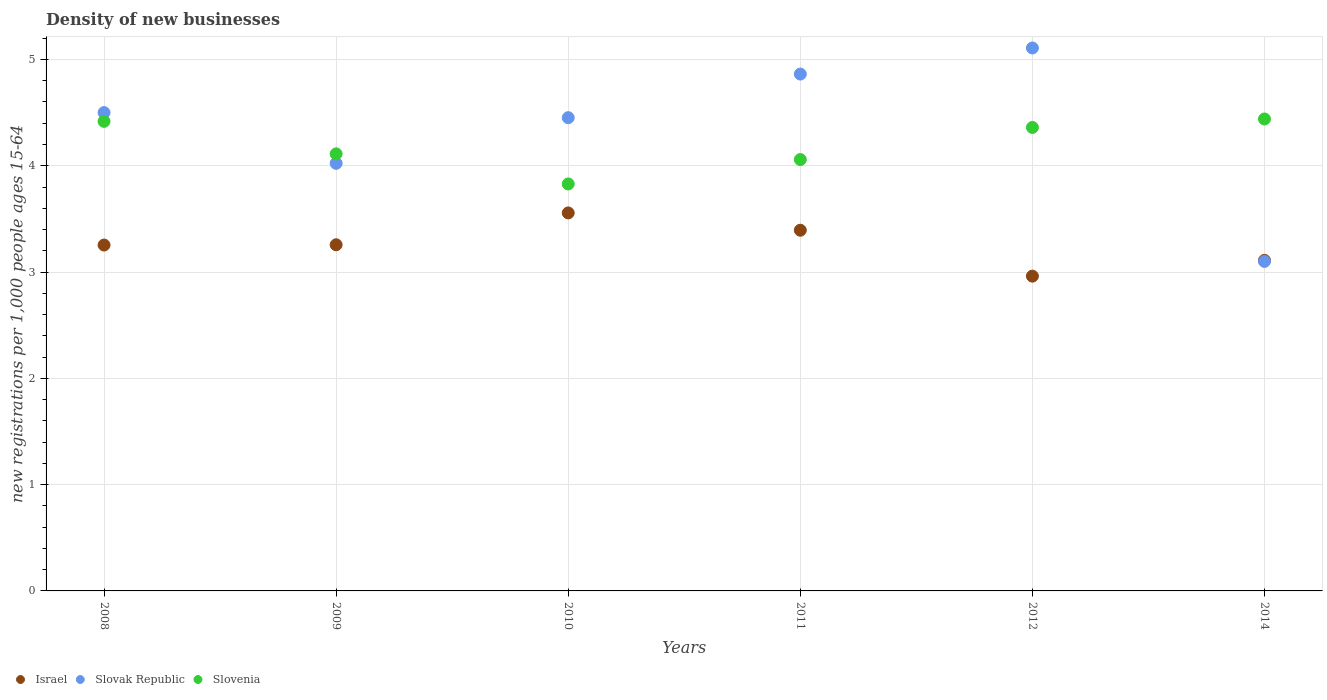How many different coloured dotlines are there?
Offer a very short reply. 3. Is the number of dotlines equal to the number of legend labels?
Make the answer very short. Yes. What is the number of new registrations in Israel in 2012?
Your response must be concise. 2.96. Across all years, what is the maximum number of new registrations in Slovenia?
Offer a terse response. 4.44. Across all years, what is the minimum number of new registrations in Slovenia?
Make the answer very short. 3.83. What is the total number of new registrations in Slovenia in the graph?
Provide a short and direct response. 25.22. What is the difference between the number of new registrations in Slovak Republic in 2008 and that in 2010?
Your answer should be very brief. 0.05. What is the difference between the number of new registrations in Israel in 2014 and the number of new registrations in Slovenia in 2010?
Provide a succinct answer. -0.72. What is the average number of new registrations in Israel per year?
Offer a very short reply. 3.26. In the year 2014, what is the difference between the number of new registrations in Slovenia and number of new registrations in Slovak Republic?
Provide a succinct answer. 1.34. What is the ratio of the number of new registrations in Slovenia in 2011 to that in 2012?
Provide a short and direct response. 0.93. Is the difference between the number of new registrations in Slovenia in 2008 and 2011 greater than the difference between the number of new registrations in Slovak Republic in 2008 and 2011?
Your answer should be very brief. Yes. What is the difference between the highest and the second highest number of new registrations in Slovenia?
Offer a terse response. 0.02. What is the difference between the highest and the lowest number of new registrations in Israel?
Your answer should be compact. 0.59. In how many years, is the number of new registrations in Slovenia greater than the average number of new registrations in Slovenia taken over all years?
Your response must be concise. 3. Is it the case that in every year, the sum of the number of new registrations in Slovenia and number of new registrations in Israel  is greater than the number of new registrations in Slovak Republic?
Make the answer very short. Yes. Is the number of new registrations in Slovak Republic strictly greater than the number of new registrations in Slovenia over the years?
Ensure brevity in your answer.  No. What is the difference between two consecutive major ticks on the Y-axis?
Provide a short and direct response. 1. Does the graph contain any zero values?
Your answer should be compact. No. How many legend labels are there?
Keep it short and to the point. 3. How are the legend labels stacked?
Your answer should be compact. Horizontal. What is the title of the graph?
Ensure brevity in your answer.  Density of new businesses. What is the label or title of the Y-axis?
Provide a succinct answer. New registrations per 1,0 people ages 15-64. What is the new registrations per 1,000 people ages 15-64 of Israel in 2008?
Give a very brief answer. 3.25. What is the new registrations per 1,000 people ages 15-64 in Slovak Republic in 2008?
Give a very brief answer. 4.5. What is the new registrations per 1,000 people ages 15-64 of Slovenia in 2008?
Your response must be concise. 4.42. What is the new registrations per 1,000 people ages 15-64 in Israel in 2009?
Make the answer very short. 3.26. What is the new registrations per 1,000 people ages 15-64 of Slovak Republic in 2009?
Your answer should be compact. 4.02. What is the new registrations per 1,000 people ages 15-64 of Slovenia in 2009?
Ensure brevity in your answer.  4.11. What is the new registrations per 1,000 people ages 15-64 of Israel in 2010?
Ensure brevity in your answer.  3.56. What is the new registrations per 1,000 people ages 15-64 in Slovak Republic in 2010?
Offer a terse response. 4.45. What is the new registrations per 1,000 people ages 15-64 of Slovenia in 2010?
Offer a very short reply. 3.83. What is the new registrations per 1,000 people ages 15-64 of Israel in 2011?
Your answer should be very brief. 3.39. What is the new registrations per 1,000 people ages 15-64 in Slovak Republic in 2011?
Make the answer very short. 4.86. What is the new registrations per 1,000 people ages 15-64 of Slovenia in 2011?
Your answer should be very brief. 4.06. What is the new registrations per 1,000 people ages 15-64 of Israel in 2012?
Ensure brevity in your answer.  2.96. What is the new registrations per 1,000 people ages 15-64 of Slovak Republic in 2012?
Provide a succinct answer. 5.11. What is the new registrations per 1,000 people ages 15-64 of Slovenia in 2012?
Your answer should be compact. 4.36. What is the new registrations per 1,000 people ages 15-64 in Israel in 2014?
Make the answer very short. 3.11. What is the new registrations per 1,000 people ages 15-64 in Slovak Republic in 2014?
Provide a succinct answer. 3.1. What is the new registrations per 1,000 people ages 15-64 of Slovenia in 2014?
Offer a terse response. 4.44. Across all years, what is the maximum new registrations per 1,000 people ages 15-64 in Israel?
Offer a very short reply. 3.56. Across all years, what is the maximum new registrations per 1,000 people ages 15-64 in Slovak Republic?
Offer a very short reply. 5.11. Across all years, what is the maximum new registrations per 1,000 people ages 15-64 in Slovenia?
Your answer should be very brief. 4.44. Across all years, what is the minimum new registrations per 1,000 people ages 15-64 of Israel?
Keep it short and to the point. 2.96. Across all years, what is the minimum new registrations per 1,000 people ages 15-64 in Slovenia?
Provide a short and direct response. 3.83. What is the total new registrations per 1,000 people ages 15-64 in Israel in the graph?
Offer a terse response. 19.53. What is the total new registrations per 1,000 people ages 15-64 of Slovak Republic in the graph?
Make the answer very short. 26.05. What is the total new registrations per 1,000 people ages 15-64 of Slovenia in the graph?
Your answer should be very brief. 25.22. What is the difference between the new registrations per 1,000 people ages 15-64 of Israel in 2008 and that in 2009?
Ensure brevity in your answer.  -0. What is the difference between the new registrations per 1,000 people ages 15-64 in Slovak Republic in 2008 and that in 2009?
Your answer should be compact. 0.48. What is the difference between the new registrations per 1,000 people ages 15-64 of Slovenia in 2008 and that in 2009?
Provide a short and direct response. 0.31. What is the difference between the new registrations per 1,000 people ages 15-64 of Israel in 2008 and that in 2010?
Provide a short and direct response. -0.3. What is the difference between the new registrations per 1,000 people ages 15-64 in Slovak Republic in 2008 and that in 2010?
Provide a succinct answer. 0.05. What is the difference between the new registrations per 1,000 people ages 15-64 of Slovenia in 2008 and that in 2010?
Offer a terse response. 0.59. What is the difference between the new registrations per 1,000 people ages 15-64 of Israel in 2008 and that in 2011?
Provide a short and direct response. -0.14. What is the difference between the new registrations per 1,000 people ages 15-64 of Slovak Republic in 2008 and that in 2011?
Your answer should be very brief. -0.36. What is the difference between the new registrations per 1,000 people ages 15-64 in Slovenia in 2008 and that in 2011?
Offer a terse response. 0.36. What is the difference between the new registrations per 1,000 people ages 15-64 of Israel in 2008 and that in 2012?
Keep it short and to the point. 0.29. What is the difference between the new registrations per 1,000 people ages 15-64 in Slovak Republic in 2008 and that in 2012?
Your answer should be very brief. -0.61. What is the difference between the new registrations per 1,000 people ages 15-64 in Slovenia in 2008 and that in 2012?
Your answer should be compact. 0.06. What is the difference between the new registrations per 1,000 people ages 15-64 in Israel in 2008 and that in 2014?
Provide a short and direct response. 0.14. What is the difference between the new registrations per 1,000 people ages 15-64 of Slovak Republic in 2008 and that in 2014?
Offer a very short reply. 1.4. What is the difference between the new registrations per 1,000 people ages 15-64 in Slovenia in 2008 and that in 2014?
Offer a very short reply. -0.02. What is the difference between the new registrations per 1,000 people ages 15-64 in Israel in 2009 and that in 2010?
Ensure brevity in your answer.  -0.3. What is the difference between the new registrations per 1,000 people ages 15-64 in Slovak Republic in 2009 and that in 2010?
Offer a terse response. -0.43. What is the difference between the new registrations per 1,000 people ages 15-64 of Slovenia in 2009 and that in 2010?
Keep it short and to the point. 0.28. What is the difference between the new registrations per 1,000 people ages 15-64 of Israel in 2009 and that in 2011?
Your response must be concise. -0.14. What is the difference between the new registrations per 1,000 people ages 15-64 in Slovak Republic in 2009 and that in 2011?
Provide a succinct answer. -0.84. What is the difference between the new registrations per 1,000 people ages 15-64 of Slovenia in 2009 and that in 2011?
Ensure brevity in your answer.  0.05. What is the difference between the new registrations per 1,000 people ages 15-64 of Israel in 2009 and that in 2012?
Your response must be concise. 0.3. What is the difference between the new registrations per 1,000 people ages 15-64 in Slovak Republic in 2009 and that in 2012?
Offer a terse response. -1.09. What is the difference between the new registrations per 1,000 people ages 15-64 of Slovenia in 2009 and that in 2012?
Your response must be concise. -0.25. What is the difference between the new registrations per 1,000 people ages 15-64 in Israel in 2009 and that in 2014?
Offer a terse response. 0.15. What is the difference between the new registrations per 1,000 people ages 15-64 in Slovak Republic in 2009 and that in 2014?
Keep it short and to the point. 0.92. What is the difference between the new registrations per 1,000 people ages 15-64 in Slovenia in 2009 and that in 2014?
Keep it short and to the point. -0.33. What is the difference between the new registrations per 1,000 people ages 15-64 in Israel in 2010 and that in 2011?
Provide a short and direct response. 0.16. What is the difference between the new registrations per 1,000 people ages 15-64 of Slovak Republic in 2010 and that in 2011?
Offer a terse response. -0.41. What is the difference between the new registrations per 1,000 people ages 15-64 of Slovenia in 2010 and that in 2011?
Make the answer very short. -0.23. What is the difference between the new registrations per 1,000 people ages 15-64 of Israel in 2010 and that in 2012?
Your answer should be compact. 0.59. What is the difference between the new registrations per 1,000 people ages 15-64 of Slovak Republic in 2010 and that in 2012?
Keep it short and to the point. -0.66. What is the difference between the new registrations per 1,000 people ages 15-64 of Slovenia in 2010 and that in 2012?
Give a very brief answer. -0.53. What is the difference between the new registrations per 1,000 people ages 15-64 in Israel in 2010 and that in 2014?
Keep it short and to the point. 0.45. What is the difference between the new registrations per 1,000 people ages 15-64 in Slovak Republic in 2010 and that in 2014?
Make the answer very short. 1.35. What is the difference between the new registrations per 1,000 people ages 15-64 in Slovenia in 2010 and that in 2014?
Keep it short and to the point. -0.61. What is the difference between the new registrations per 1,000 people ages 15-64 in Israel in 2011 and that in 2012?
Offer a very short reply. 0.43. What is the difference between the new registrations per 1,000 people ages 15-64 in Slovak Republic in 2011 and that in 2012?
Keep it short and to the point. -0.25. What is the difference between the new registrations per 1,000 people ages 15-64 of Slovenia in 2011 and that in 2012?
Make the answer very short. -0.3. What is the difference between the new registrations per 1,000 people ages 15-64 in Israel in 2011 and that in 2014?
Keep it short and to the point. 0.28. What is the difference between the new registrations per 1,000 people ages 15-64 of Slovak Republic in 2011 and that in 2014?
Your answer should be very brief. 1.76. What is the difference between the new registrations per 1,000 people ages 15-64 in Slovenia in 2011 and that in 2014?
Your answer should be compact. -0.38. What is the difference between the new registrations per 1,000 people ages 15-64 in Israel in 2012 and that in 2014?
Provide a succinct answer. -0.15. What is the difference between the new registrations per 1,000 people ages 15-64 in Slovak Republic in 2012 and that in 2014?
Make the answer very short. 2.01. What is the difference between the new registrations per 1,000 people ages 15-64 of Slovenia in 2012 and that in 2014?
Ensure brevity in your answer.  -0.08. What is the difference between the new registrations per 1,000 people ages 15-64 of Israel in 2008 and the new registrations per 1,000 people ages 15-64 of Slovak Republic in 2009?
Ensure brevity in your answer.  -0.77. What is the difference between the new registrations per 1,000 people ages 15-64 of Israel in 2008 and the new registrations per 1,000 people ages 15-64 of Slovenia in 2009?
Your response must be concise. -0.86. What is the difference between the new registrations per 1,000 people ages 15-64 in Slovak Republic in 2008 and the new registrations per 1,000 people ages 15-64 in Slovenia in 2009?
Provide a short and direct response. 0.39. What is the difference between the new registrations per 1,000 people ages 15-64 in Israel in 2008 and the new registrations per 1,000 people ages 15-64 in Slovak Republic in 2010?
Your answer should be very brief. -1.2. What is the difference between the new registrations per 1,000 people ages 15-64 in Israel in 2008 and the new registrations per 1,000 people ages 15-64 in Slovenia in 2010?
Offer a terse response. -0.57. What is the difference between the new registrations per 1,000 people ages 15-64 in Slovak Republic in 2008 and the new registrations per 1,000 people ages 15-64 in Slovenia in 2010?
Your response must be concise. 0.67. What is the difference between the new registrations per 1,000 people ages 15-64 of Israel in 2008 and the new registrations per 1,000 people ages 15-64 of Slovak Republic in 2011?
Offer a terse response. -1.61. What is the difference between the new registrations per 1,000 people ages 15-64 of Israel in 2008 and the new registrations per 1,000 people ages 15-64 of Slovenia in 2011?
Your answer should be compact. -0.8. What is the difference between the new registrations per 1,000 people ages 15-64 of Slovak Republic in 2008 and the new registrations per 1,000 people ages 15-64 of Slovenia in 2011?
Ensure brevity in your answer.  0.44. What is the difference between the new registrations per 1,000 people ages 15-64 of Israel in 2008 and the new registrations per 1,000 people ages 15-64 of Slovak Republic in 2012?
Offer a terse response. -1.85. What is the difference between the new registrations per 1,000 people ages 15-64 of Israel in 2008 and the new registrations per 1,000 people ages 15-64 of Slovenia in 2012?
Provide a short and direct response. -1.11. What is the difference between the new registrations per 1,000 people ages 15-64 of Slovak Republic in 2008 and the new registrations per 1,000 people ages 15-64 of Slovenia in 2012?
Keep it short and to the point. 0.14. What is the difference between the new registrations per 1,000 people ages 15-64 of Israel in 2008 and the new registrations per 1,000 people ages 15-64 of Slovak Republic in 2014?
Your answer should be very brief. 0.15. What is the difference between the new registrations per 1,000 people ages 15-64 of Israel in 2008 and the new registrations per 1,000 people ages 15-64 of Slovenia in 2014?
Offer a terse response. -1.19. What is the difference between the new registrations per 1,000 people ages 15-64 in Slovak Republic in 2008 and the new registrations per 1,000 people ages 15-64 in Slovenia in 2014?
Give a very brief answer. 0.06. What is the difference between the new registrations per 1,000 people ages 15-64 in Israel in 2009 and the new registrations per 1,000 people ages 15-64 in Slovak Republic in 2010?
Ensure brevity in your answer.  -1.2. What is the difference between the new registrations per 1,000 people ages 15-64 in Israel in 2009 and the new registrations per 1,000 people ages 15-64 in Slovenia in 2010?
Offer a very short reply. -0.57. What is the difference between the new registrations per 1,000 people ages 15-64 of Slovak Republic in 2009 and the new registrations per 1,000 people ages 15-64 of Slovenia in 2010?
Offer a terse response. 0.19. What is the difference between the new registrations per 1,000 people ages 15-64 of Israel in 2009 and the new registrations per 1,000 people ages 15-64 of Slovak Republic in 2011?
Your answer should be very brief. -1.61. What is the difference between the new registrations per 1,000 people ages 15-64 in Israel in 2009 and the new registrations per 1,000 people ages 15-64 in Slovenia in 2011?
Ensure brevity in your answer.  -0.8. What is the difference between the new registrations per 1,000 people ages 15-64 of Slovak Republic in 2009 and the new registrations per 1,000 people ages 15-64 of Slovenia in 2011?
Make the answer very short. -0.04. What is the difference between the new registrations per 1,000 people ages 15-64 in Israel in 2009 and the new registrations per 1,000 people ages 15-64 in Slovak Republic in 2012?
Make the answer very short. -1.85. What is the difference between the new registrations per 1,000 people ages 15-64 of Israel in 2009 and the new registrations per 1,000 people ages 15-64 of Slovenia in 2012?
Offer a terse response. -1.1. What is the difference between the new registrations per 1,000 people ages 15-64 in Slovak Republic in 2009 and the new registrations per 1,000 people ages 15-64 in Slovenia in 2012?
Offer a very short reply. -0.34. What is the difference between the new registrations per 1,000 people ages 15-64 of Israel in 2009 and the new registrations per 1,000 people ages 15-64 of Slovak Republic in 2014?
Your response must be concise. 0.16. What is the difference between the new registrations per 1,000 people ages 15-64 in Israel in 2009 and the new registrations per 1,000 people ages 15-64 in Slovenia in 2014?
Ensure brevity in your answer.  -1.18. What is the difference between the new registrations per 1,000 people ages 15-64 in Slovak Republic in 2009 and the new registrations per 1,000 people ages 15-64 in Slovenia in 2014?
Make the answer very short. -0.42. What is the difference between the new registrations per 1,000 people ages 15-64 in Israel in 2010 and the new registrations per 1,000 people ages 15-64 in Slovak Republic in 2011?
Make the answer very short. -1.31. What is the difference between the new registrations per 1,000 people ages 15-64 of Israel in 2010 and the new registrations per 1,000 people ages 15-64 of Slovenia in 2011?
Your answer should be compact. -0.5. What is the difference between the new registrations per 1,000 people ages 15-64 of Slovak Republic in 2010 and the new registrations per 1,000 people ages 15-64 of Slovenia in 2011?
Your response must be concise. 0.39. What is the difference between the new registrations per 1,000 people ages 15-64 in Israel in 2010 and the new registrations per 1,000 people ages 15-64 in Slovak Republic in 2012?
Your answer should be compact. -1.55. What is the difference between the new registrations per 1,000 people ages 15-64 in Israel in 2010 and the new registrations per 1,000 people ages 15-64 in Slovenia in 2012?
Your answer should be very brief. -0.8. What is the difference between the new registrations per 1,000 people ages 15-64 of Slovak Republic in 2010 and the new registrations per 1,000 people ages 15-64 of Slovenia in 2012?
Your answer should be compact. 0.09. What is the difference between the new registrations per 1,000 people ages 15-64 of Israel in 2010 and the new registrations per 1,000 people ages 15-64 of Slovak Republic in 2014?
Make the answer very short. 0.46. What is the difference between the new registrations per 1,000 people ages 15-64 of Israel in 2010 and the new registrations per 1,000 people ages 15-64 of Slovenia in 2014?
Provide a succinct answer. -0.88. What is the difference between the new registrations per 1,000 people ages 15-64 of Slovak Republic in 2010 and the new registrations per 1,000 people ages 15-64 of Slovenia in 2014?
Offer a very short reply. 0.01. What is the difference between the new registrations per 1,000 people ages 15-64 in Israel in 2011 and the new registrations per 1,000 people ages 15-64 in Slovak Republic in 2012?
Provide a short and direct response. -1.71. What is the difference between the new registrations per 1,000 people ages 15-64 in Israel in 2011 and the new registrations per 1,000 people ages 15-64 in Slovenia in 2012?
Your response must be concise. -0.97. What is the difference between the new registrations per 1,000 people ages 15-64 in Slovak Republic in 2011 and the new registrations per 1,000 people ages 15-64 in Slovenia in 2012?
Offer a terse response. 0.5. What is the difference between the new registrations per 1,000 people ages 15-64 in Israel in 2011 and the new registrations per 1,000 people ages 15-64 in Slovak Republic in 2014?
Ensure brevity in your answer.  0.29. What is the difference between the new registrations per 1,000 people ages 15-64 of Israel in 2011 and the new registrations per 1,000 people ages 15-64 of Slovenia in 2014?
Offer a terse response. -1.05. What is the difference between the new registrations per 1,000 people ages 15-64 in Slovak Republic in 2011 and the new registrations per 1,000 people ages 15-64 in Slovenia in 2014?
Offer a terse response. 0.42. What is the difference between the new registrations per 1,000 people ages 15-64 of Israel in 2012 and the new registrations per 1,000 people ages 15-64 of Slovak Republic in 2014?
Your response must be concise. -0.14. What is the difference between the new registrations per 1,000 people ages 15-64 of Israel in 2012 and the new registrations per 1,000 people ages 15-64 of Slovenia in 2014?
Ensure brevity in your answer.  -1.48. What is the difference between the new registrations per 1,000 people ages 15-64 in Slovak Republic in 2012 and the new registrations per 1,000 people ages 15-64 in Slovenia in 2014?
Your response must be concise. 0.67. What is the average new registrations per 1,000 people ages 15-64 of Israel per year?
Keep it short and to the point. 3.26. What is the average new registrations per 1,000 people ages 15-64 in Slovak Republic per year?
Provide a short and direct response. 4.34. What is the average new registrations per 1,000 people ages 15-64 in Slovenia per year?
Keep it short and to the point. 4.2. In the year 2008, what is the difference between the new registrations per 1,000 people ages 15-64 of Israel and new registrations per 1,000 people ages 15-64 of Slovak Republic?
Your answer should be compact. -1.25. In the year 2008, what is the difference between the new registrations per 1,000 people ages 15-64 in Israel and new registrations per 1,000 people ages 15-64 in Slovenia?
Your answer should be very brief. -1.16. In the year 2008, what is the difference between the new registrations per 1,000 people ages 15-64 in Slovak Republic and new registrations per 1,000 people ages 15-64 in Slovenia?
Provide a succinct answer. 0.08. In the year 2009, what is the difference between the new registrations per 1,000 people ages 15-64 of Israel and new registrations per 1,000 people ages 15-64 of Slovak Republic?
Make the answer very short. -0.77. In the year 2009, what is the difference between the new registrations per 1,000 people ages 15-64 in Israel and new registrations per 1,000 people ages 15-64 in Slovenia?
Provide a short and direct response. -0.86. In the year 2009, what is the difference between the new registrations per 1,000 people ages 15-64 in Slovak Republic and new registrations per 1,000 people ages 15-64 in Slovenia?
Your response must be concise. -0.09. In the year 2010, what is the difference between the new registrations per 1,000 people ages 15-64 in Israel and new registrations per 1,000 people ages 15-64 in Slovak Republic?
Ensure brevity in your answer.  -0.9. In the year 2010, what is the difference between the new registrations per 1,000 people ages 15-64 in Israel and new registrations per 1,000 people ages 15-64 in Slovenia?
Make the answer very short. -0.27. In the year 2010, what is the difference between the new registrations per 1,000 people ages 15-64 in Slovak Republic and new registrations per 1,000 people ages 15-64 in Slovenia?
Provide a succinct answer. 0.62. In the year 2011, what is the difference between the new registrations per 1,000 people ages 15-64 in Israel and new registrations per 1,000 people ages 15-64 in Slovak Republic?
Keep it short and to the point. -1.47. In the year 2011, what is the difference between the new registrations per 1,000 people ages 15-64 in Israel and new registrations per 1,000 people ages 15-64 in Slovenia?
Offer a very short reply. -0.66. In the year 2011, what is the difference between the new registrations per 1,000 people ages 15-64 of Slovak Republic and new registrations per 1,000 people ages 15-64 of Slovenia?
Provide a succinct answer. 0.8. In the year 2012, what is the difference between the new registrations per 1,000 people ages 15-64 in Israel and new registrations per 1,000 people ages 15-64 in Slovak Republic?
Your answer should be compact. -2.15. In the year 2012, what is the difference between the new registrations per 1,000 people ages 15-64 in Israel and new registrations per 1,000 people ages 15-64 in Slovenia?
Provide a succinct answer. -1.4. In the year 2012, what is the difference between the new registrations per 1,000 people ages 15-64 of Slovak Republic and new registrations per 1,000 people ages 15-64 of Slovenia?
Offer a very short reply. 0.75. In the year 2014, what is the difference between the new registrations per 1,000 people ages 15-64 of Israel and new registrations per 1,000 people ages 15-64 of Slovenia?
Your response must be concise. -1.33. In the year 2014, what is the difference between the new registrations per 1,000 people ages 15-64 in Slovak Republic and new registrations per 1,000 people ages 15-64 in Slovenia?
Your response must be concise. -1.34. What is the ratio of the new registrations per 1,000 people ages 15-64 in Israel in 2008 to that in 2009?
Keep it short and to the point. 1. What is the ratio of the new registrations per 1,000 people ages 15-64 of Slovak Republic in 2008 to that in 2009?
Your answer should be compact. 1.12. What is the ratio of the new registrations per 1,000 people ages 15-64 in Slovenia in 2008 to that in 2009?
Your answer should be compact. 1.07. What is the ratio of the new registrations per 1,000 people ages 15-64 in Israel in 2008 to that in 2010?
Offer a terse response. 0.92. What is the ratio of the new registrations per 1,000 people ages 15-64 of Slovak Republic in 2008 to that in 2010?
Keep it short and to the point. 1.01. What is the ratio of the new registrations per 1,000 people ages 15-64 of Slovenia in 2008 to that in 2010?
Give a very brief answer. 1.15. What is the ratio of the new registrations per 1,000 people ages 15-64 in Israel in 2008 to that in 2011?
Ensure brevity in your answer.  0.96. What is the ratio of the new registrations per 1,000 people ages 15-64 in Slovak Republic in 2008 to that in 2011?
Make the answer very short. 0.93. What is the ratio of the new registrations per 1,000 people ages 15-64 of Slovenia in 2008 to that in 2011?
Your response must be concise. 1.09. What is the ratio of the new registrations per 1,000 people ages 15-64 in Israel in 2008 to that in 2012?
Your answer should be very brief. 1.1. What is the ratio of the new registrations per 1,000 people ages 15-64 in Slovak Republic in 2008 to that in 2012?
Give a very brief answer. 0.88. What is the ratio of the new registrations per 1,000 people ages 15-64 in Slovenia in 2008 to that in 2012?
Give a very brief answer. 1.01. What is the ratio of the new registrations per 1,000 people ages 15-64 in Israel in 2008 to that in 2014?
Make the answer very short. 1.05. What is the ratio of the new registrations per 1,000 people ages 15-64 in Slovak Republic in 2008 to that in 2014?
Offer a very short reply. 1.45. What is the ratio of the new registrations per 1,000 people ages 15-64 in Slovenia in 2008 to that in 2014?
Provide a succinct answer. 0.99. What is the ratio of the new registrations per 1,000 people ages 15-64 in Israel in 2009 to that in 2010?
Your answer should be compact. 0.92. What is the ratio of the new registrations per 1,000 people ages 15-64 of Slovak Republic in 2009 to that in 2010?
Make the answer very short. 0.9. What is the ratio of the new registrations per 1,000 people ages 15-64 in Slovenia in 2009 to that in 2010?
Keep it short and to the point. 1.07. What is the ratio of the new registrations per 1,000 people ages 15-64 of Israel in 2009 to that in 2011?
Your response must be concise. 0.96. What is the ratio of the new registrations per 1,000 people ages 15-64 of Slovak Republic in 2009 to that in 2011?
Your response must be concise. 0.83. What is the ratio of the new registrations per 1,000 people ages 15-64 in Slovenia in 2009 to that in 2011?
Your answer should be compact. 1.01. What is the ratio of the new registrations per 1,000 people ages 15-64 of Israel in 2009 to that in 2012?
Give a very brief answer. 1.1. What is the ratio of the new registrations per 1,000 people ages 15-64 in Slovak Republic in 2009 to that in 2012?
Your answer should be very brief. 0.79. What is the ratio of the new registrations per 1,000 people ages 15-64 of Slovenia in 2009 to that in 2012?
Offer a very short reply. 0.94. What is the ratio of the new registrations per 1,000 people ages 15-64 of Israel in 2009 to that in 2014?
Your response must be concise. 1.05. What is the ratio of the new registrations per 1,000 people ages 15-64 in Slovak Republic in 2009 to that in 2014?
Offer a terse response. 1.3. What is the ratio of the new registrations per 1,000 people ages 15-64 in Slovenia in 2009 to that in 2014?
Provide a short and direct response. 0.93. What is the ratio of the new registrations per 1,000 people ages 15-64 of Israel in 2010 to that in 2011?
Keep it short and to the point. 1.05. What is the ratio of the new registrations per 1,000 people ages 15-64 of Slovak Republic in 2010 to that in 2011?
Make the answer very short. 0.92. What is the ratio of the new registrations per 1,000 people ages 15-64 in Slovenia in 2010 to that in 2011?
Provide a short and direct response. 0.94. What is the ratio of the new registrations per 1,000 people ages 15-64 of Israel in 2010 to that in 2012?
Your answer should be very brief. 1.2. What is the ratio of the new registrations per 1,000 people ages 15-64 in Slovak Republic in 2010 to that in 2012?
Keep it short and to the point. 0.87. What is the ratio of the new registrations per 1,000 people ages 15-64 of Slovenia in 2010 to that in 2012?
Make the answer very short. 0.88. What is the ratio of the new registrations per 1,000 people ages 15-64 in Israel in 2010 to that in 2014?
Your response must be concise. 1.14. What is the ratio of the new registrations per 1,000 people ages 15-64 in Slovak Republic in 2010 to that in 2014?
Provide a succinct answer. 1.44. What is the ratio of the new registrations per 1,000 people ages 15-64 of Slovenia in 2010 to that in 2014?
Make the answer very short. 0.86. What is the ratio of the new registrations per 1,000 people ages 15-64 of Israel in 2011 to that in 2012?
Provide a succinct answer. 1.15. What is the ratio of the new registrations per 1,000 people ages 15-64 of Slovenia in 2011 to that in 2012?
Provide a short and direct response. 0.93. What is the ratio of the new registrations per 1,000 people ages 15-64 in Israel in 2011 to that in 2014?
Your response must be concise. 1.09. What is the ratio of the new registrations per 1,000 people ages 15-64 in Slovak Republic in 2011 to that in 2014?
Your answer should be very brief. 1.57. What is the ratio of the new registrations per 1,000 people ages 15-64 of Slovenia in 2011 to that in 2014?
Provide a succinct answer. 0.91. What is the ratio of the new registrations per 1,000 people ages 15-64 of Israel in 2012 to that in 2014?
Provide a succinct answer. 0.95. What is the ratio of the new registrations per 1,000 people ages 15-64 of Slovak Republic in 2012 to that in 2014?
Your answer should be compact. 1.65. What is the ratio of the new registrations per 1,000 people ages 15-64 of Slovenia in 2012 to that in 2014?
Make the answer very short. 0.98. What is the difference between the highest and the second highest new registrations per 1,000 people ages 15-64 in Israel?
Offer a very short reply. 0.16. What is the difference between the highest and the second highest new registrations per 1,000 people ages 15-64 of Slovak Republic?
Provide a succinct answer. 0.25. What is the difference between the highest and the second highest new registrations per 1,000 people ages 15-64 in Slovenia?
Offer a very short reply. 0.02. What is the difference between the highest and the lowest new registrations per 1,000 people ages 15-64 of Israel?
Offer a terse response. 0.59. What is the difference between the highest and the lowest new registrations per 1,000 people ages 15-64 in Slovak Republic?
Your answer should be very brief. 2.01. What is the difference between the highest and the lowest new registrations per 1,000 people ages 15-64 in Slovenia?
Your answer should be very brief. 0.61. 